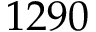Convert formula to latex. <formula><loc_0><loc_0><loc_500><loc_500>1 2 9 0</formula> 